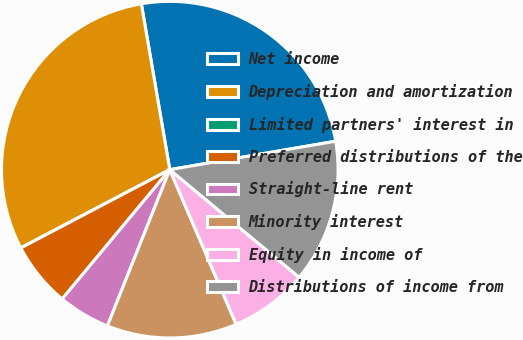Convert chart to OTSL. <chart><loc_0><loc_0><loc_500><loc_500><pie_chart><fcel>Net income<fcel>Depreciation and amortization<fcel>Limited partners' interest in<fcel>Preferred distributions of the<fcel>Straight-line rent<fcel>Minority interest<fcel>Equity in income of<fcel>Distributions of income from<nl><fcel>25.0%<fcel>30.0%<fcel>0.0%<fcel>6.25%<fcel>5.0%<fcel>12.5%<fcel>7.5%<fcel>13.75%<nl></chart> 